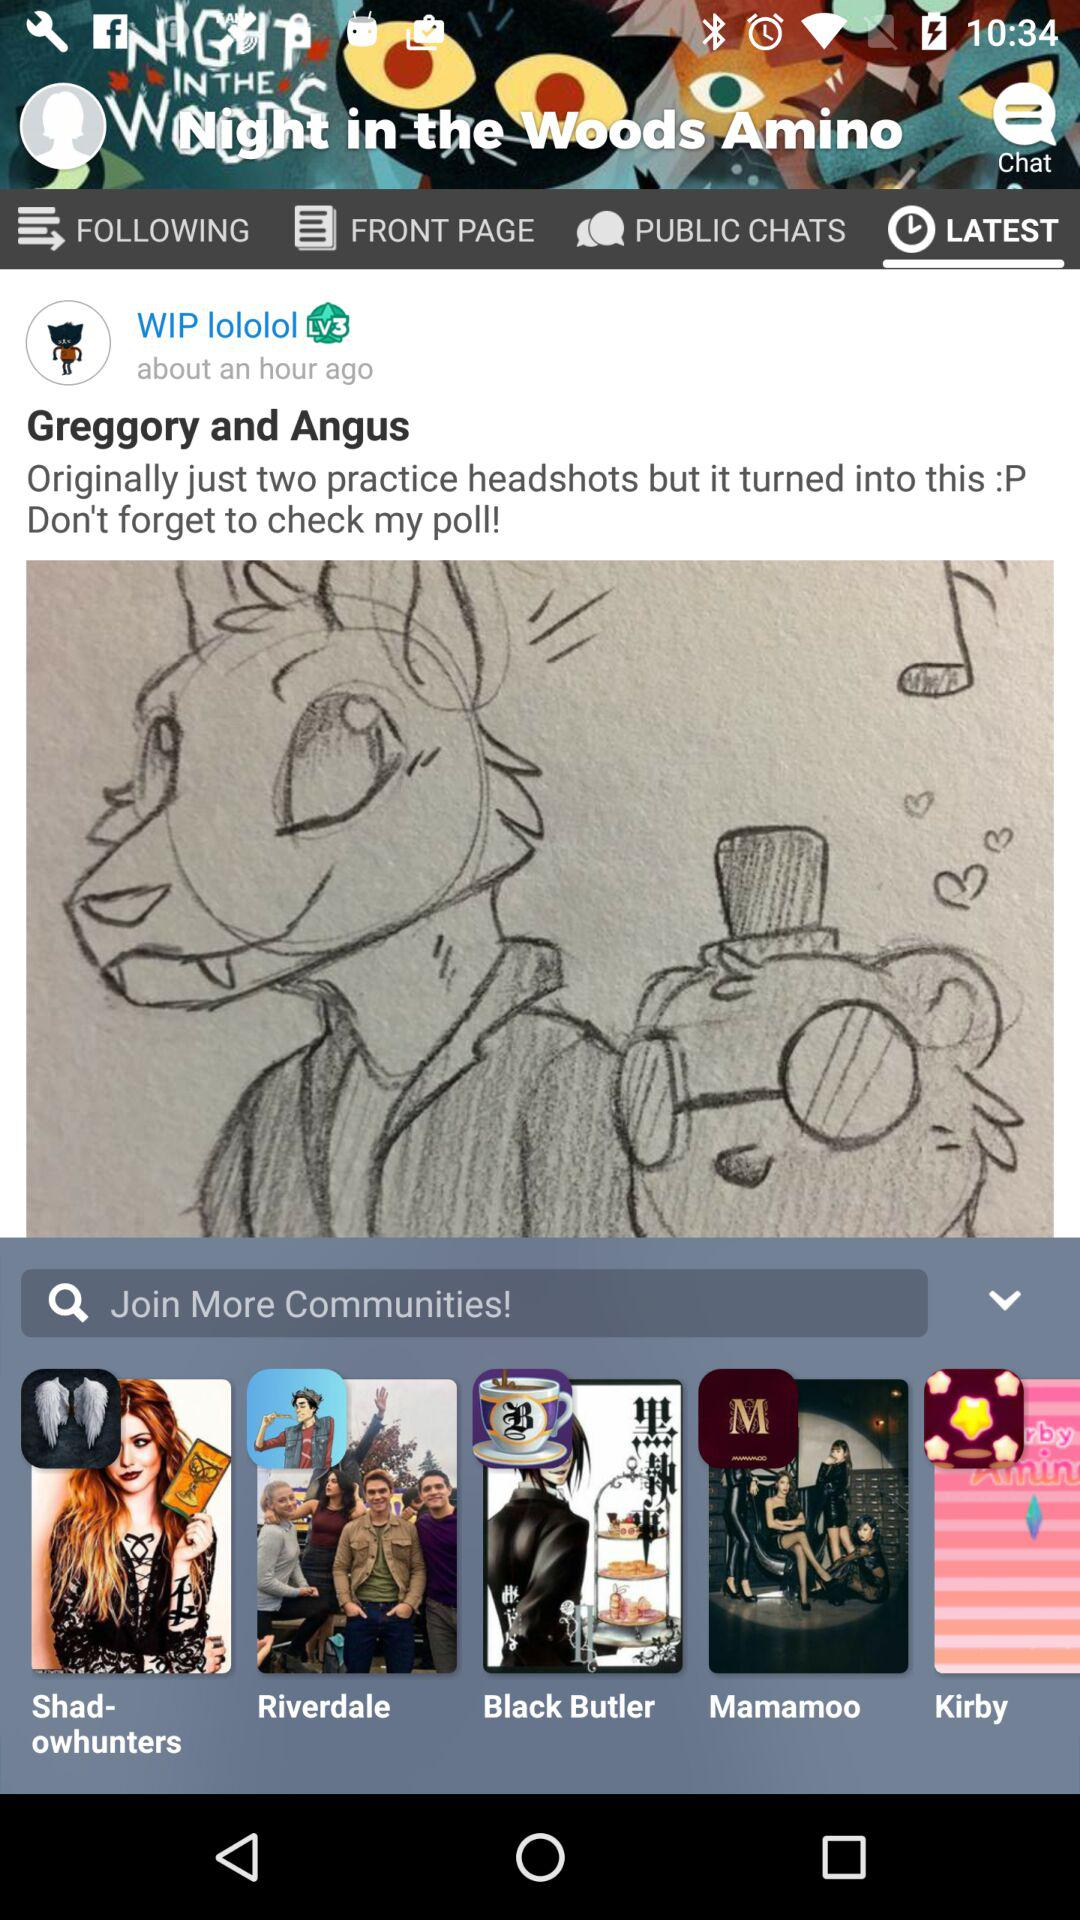What is the name of the application? The name of the application is "Night in the Woods Amino". 